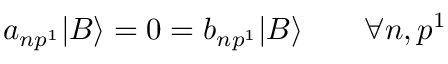Convert formula to latex. <formula><loc_0><loc_0><loc_500><loc_500>a _ { n p ^ { 1 } } | B \rangle = 0 = b _ { n p ^ { 1 } } | B \rangle \quad \forall n , p ^ { 1 }</formula> 